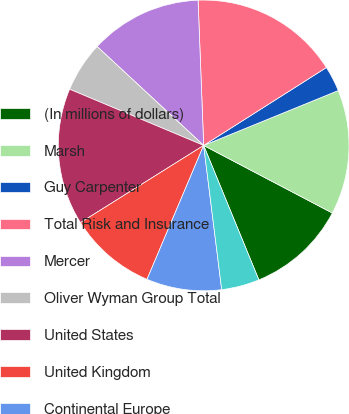Convert chart to OTSL. <chart><loc_0><loc_0><loc_500><loc_500><pie_chart><fcel>(In millions of dollars)<fcel>Marsh<fcel>Guy Carpenter<fcel>Total Risk and Insurance<fcel>Mercer<fcel>Oliver Wyman Group Total<fcel>United States<fcel>United Kingdom<fcel>Continental Europe<fcel>Asia Pacific<nl><fcel>11.1%<fcel>13.86%<fcel>2.84%<fcel>16.61%<fcel>12.48%<fcel>5.59%<fcel>15.23%<fcel>9.72%<fcel>8.35%<fcel>4.22%<nl></chart> 